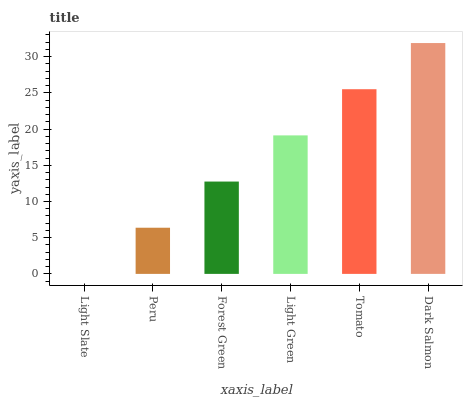Is Light Slate the minimum?
Answer yes or no. Yes. Is Dark Salmon the maximum?
Answer yes or no. Yes. Is Peru the minimum?
Answer yes or no. No. Is Peru the maximum?
Answer yes or no. No. Is Peru greater than Light Slate?
Answer yes or no. Yes. Is Light Slate less than Peru?
Answer yes or no. Yes. Is Light Slate greater than Peru?
Answer yes or no. No. Is Peru less than Light Slate?
Answer yes or no. No. Is Light Green the high median?
Answer yes or no. Yes. Is Forest Green the low median?
Answer yes or no. Yes. Is Tomato the high median?
Answer yes or no. No. Is Peru the low median?
Answer yes or no. No. 